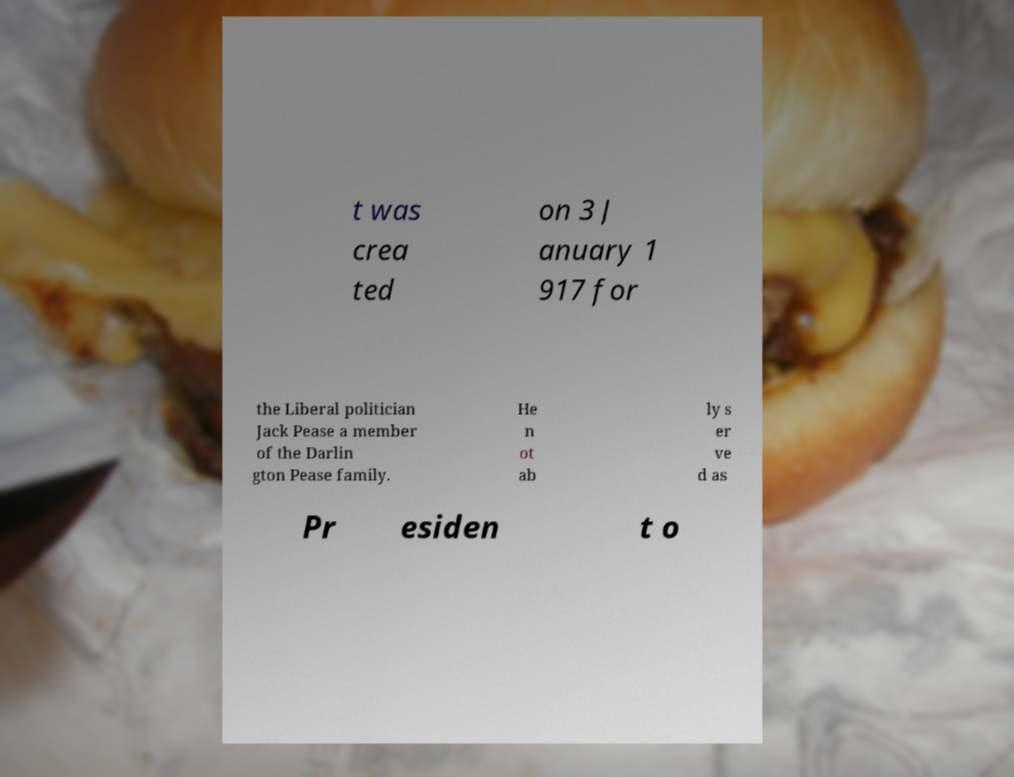Please identify and transcribe the text found in this image. t was crea ted on 3 J anuary 1 917 for the Liberal politician Jack Pease a member of the Darlin gton Pease family. He n ot ab ly s er ve d as Pr esiden t o 